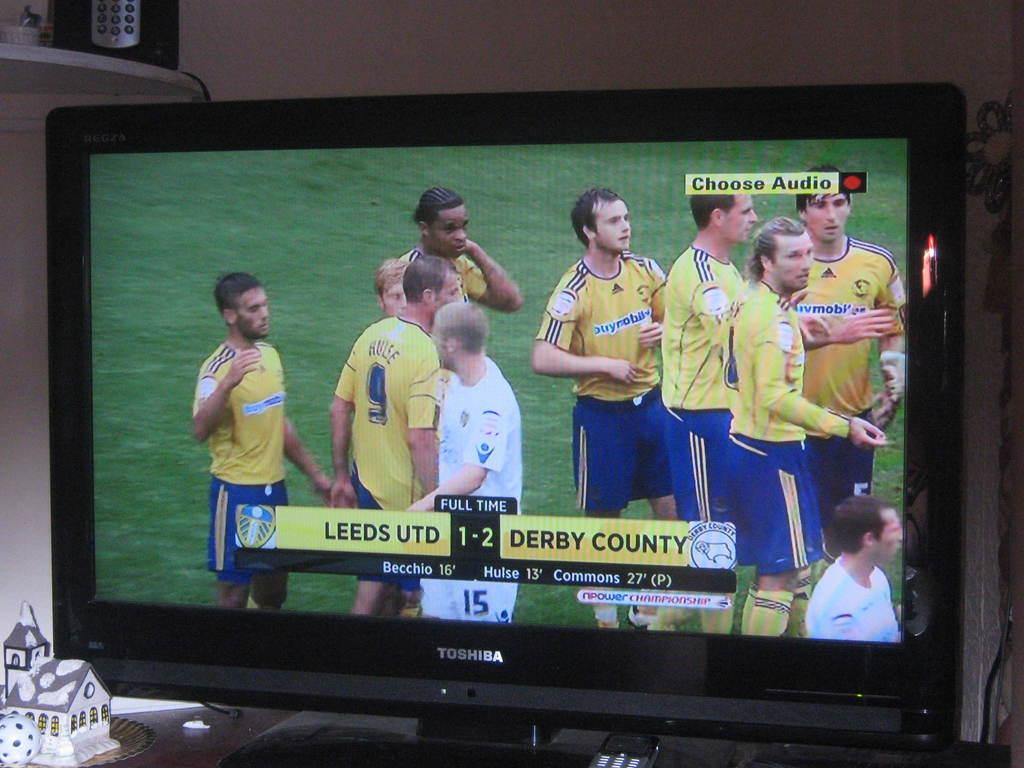<image>
Describe the image concisely. some soccer players from Leeds UTD and Derby County 